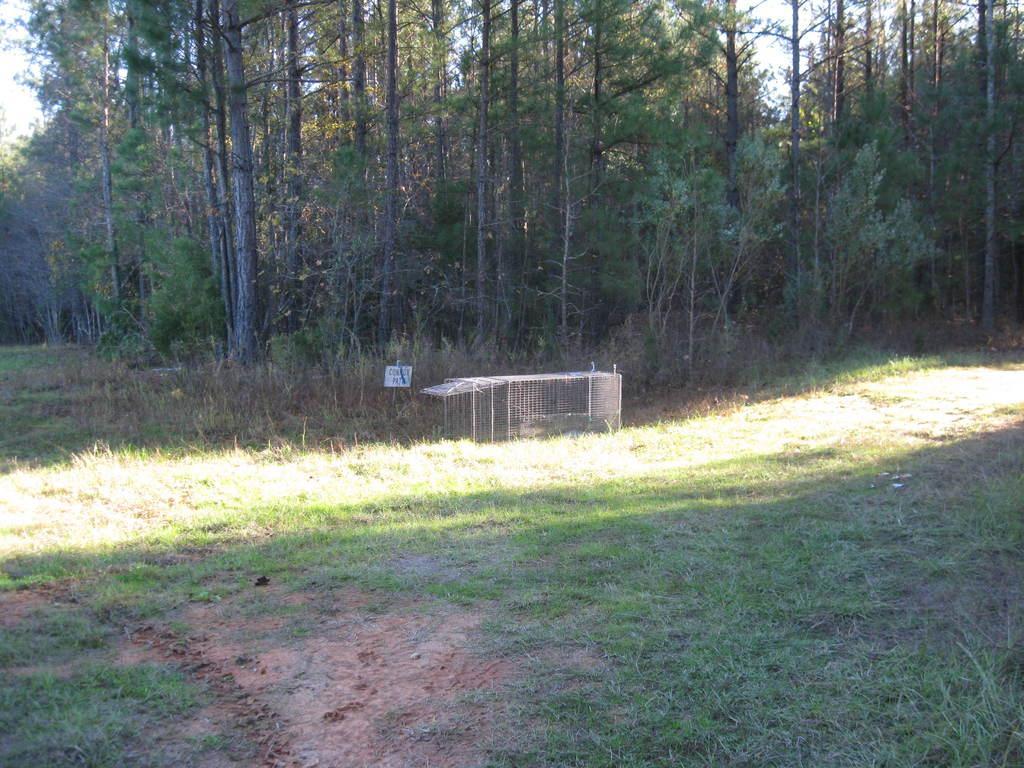Please provide a concise description of this image. In the center of the image we can see a mesh. At the bottom there is grass. In the background there are trees and sky. 